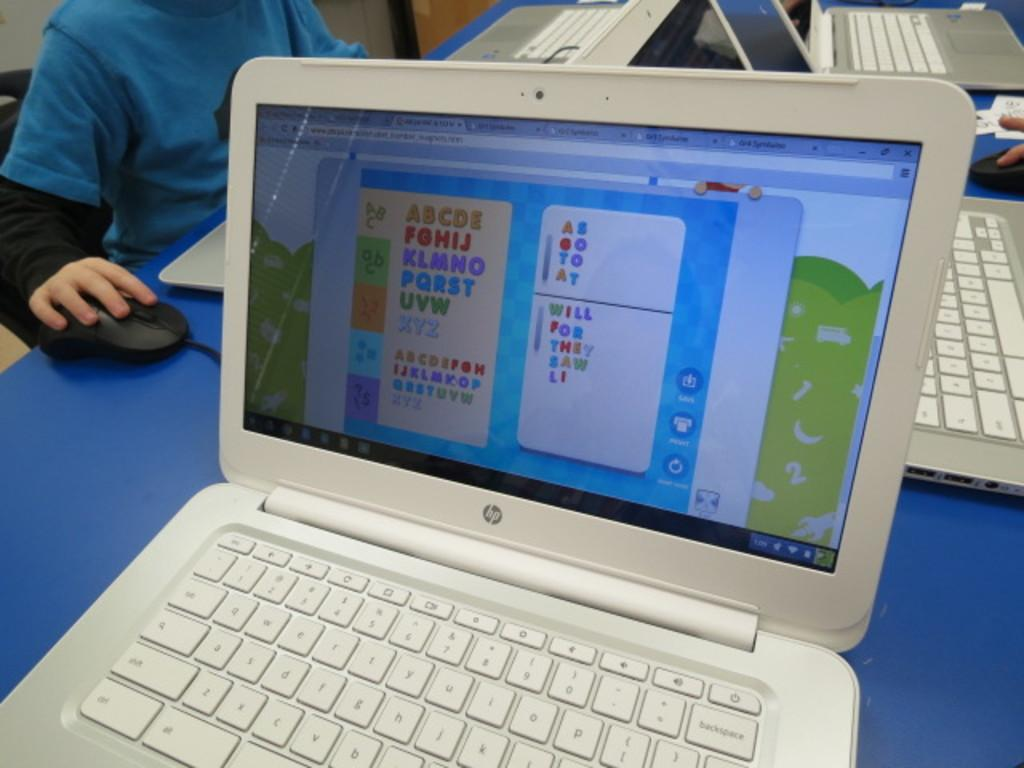<image>
Summarize the visual content of the image. An open white colored HP laptop with an educational game on the screen. 